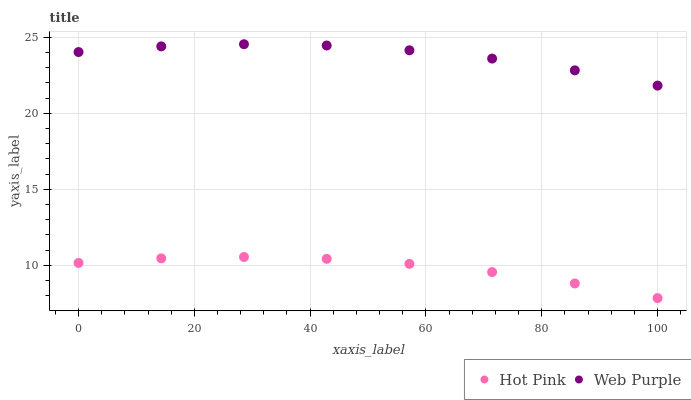Does Hot Pink have the minimum area under the curve?
Answer yes or no. Yes. Does Web Purple have the maximum area under the curve?
Answer yes or no. Yes. Does Hot Pink have the maximum area under the curve?
Answer yes or no. No. Is Hot Pink the smoothest?
Answer yes or no. Yes. Is Web Purple the roughest?
Answer yes or no. Yes. Is Hot Pink the roughest?
Answer yes or no. No. Does Hot Pink have the lowest value?
Answer yes or no. Yes. Does Web Purple have the highest value?
Answer yes or no. Yes. Does Hot Pink have the highest value?
Answer yes or no. No. Is Hot Pink less than Web Purple?
Answer yes or no. Yes. Is Web Purple greater than Hot Pink?
Answer yes or no. Yes. Does Hot Pink intersect Web Purple?
Answer yes or no. No. 